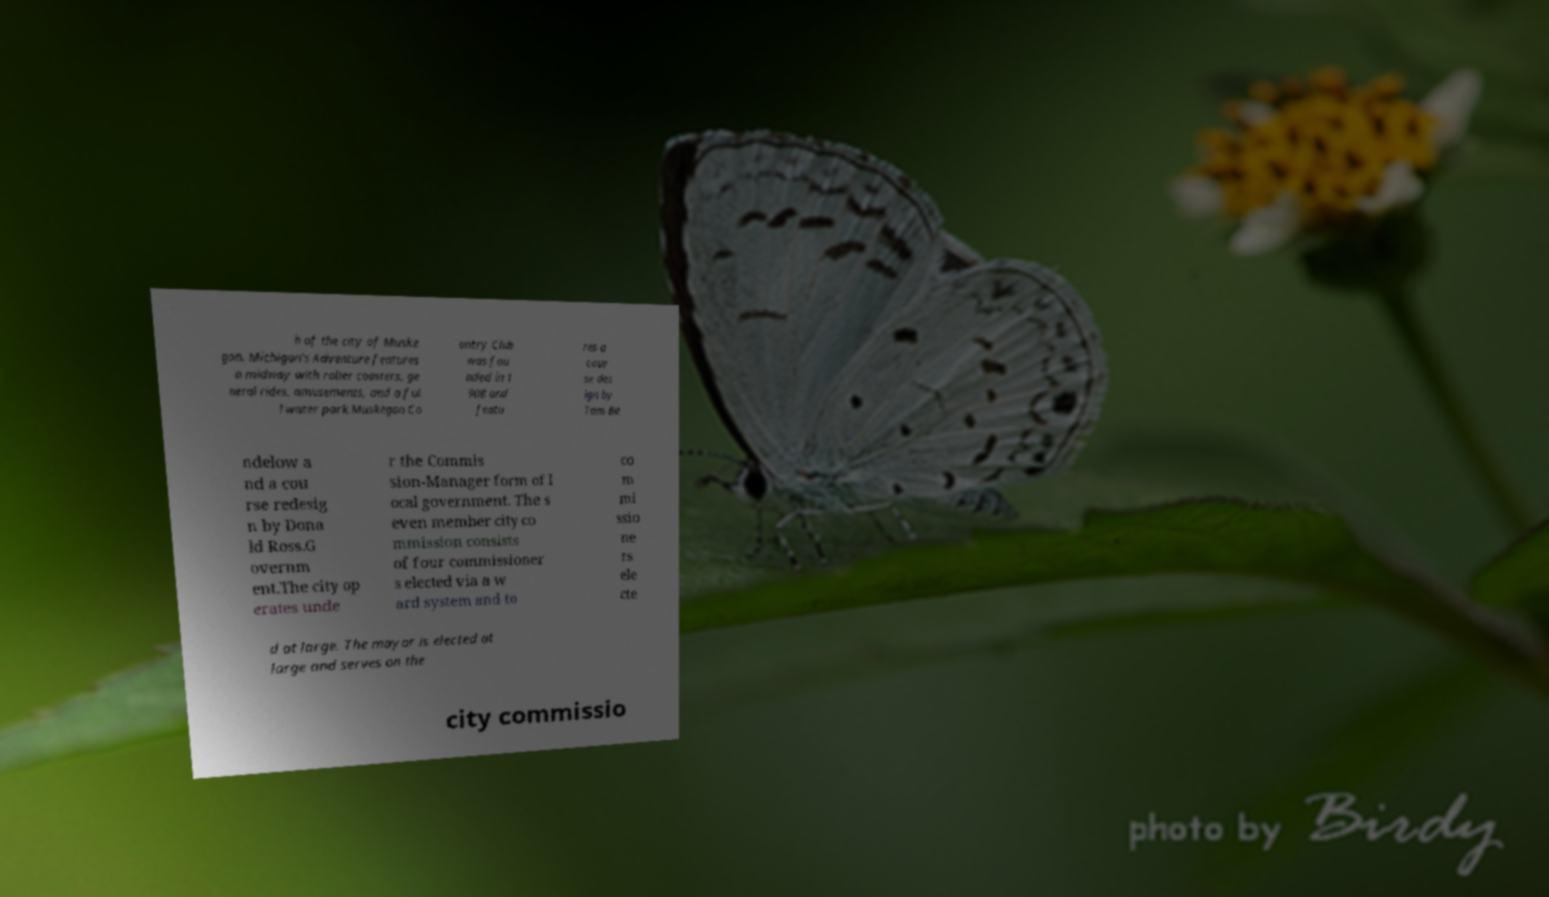For documentation purposes, I need the text within this image transcribed. Could you provide that? h of the city of Muske gon. Michigan's Adventure features a midway with roller coasters, ge neral rides, amusements, and a ful l water park.Muskegon Co untry Club was fou nded in 1 908 and featu res a cour se des ign by Tom Be ndelow a nd a cou rse redesig n by Dona ld Ross.G overnm ent.The city op erates unde r the Commis sion-Manager form of l ocal government. The s even member city co mmission consists of four commissioner s elected via a w ard system and to co m mi ssio ne rs ele cte d at large. The mayor is elected at large and serves on the city commissio 